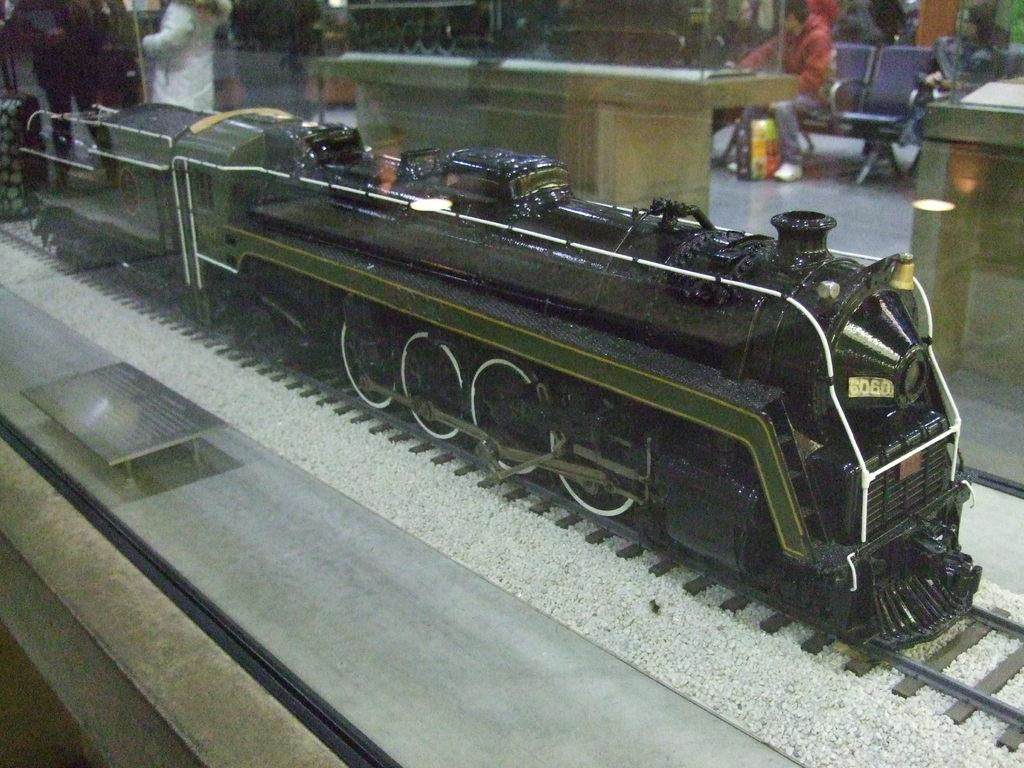What is the main subject of the image? The main subject of the image is a train on a track. What is present on the surface in the image? There is a board on the surface in the image. What can be seen in the background of the image? Tables, people sitting on chairs, and people standing are visible in the background of the image. What type of marble is being used as a tabletop in the image? There is no marble present in the image; it features a train on a track, a board on the surface, and people sitting on chairs and standing in the background. How many pets can be seen in the image? There are no pets visible in the image. 